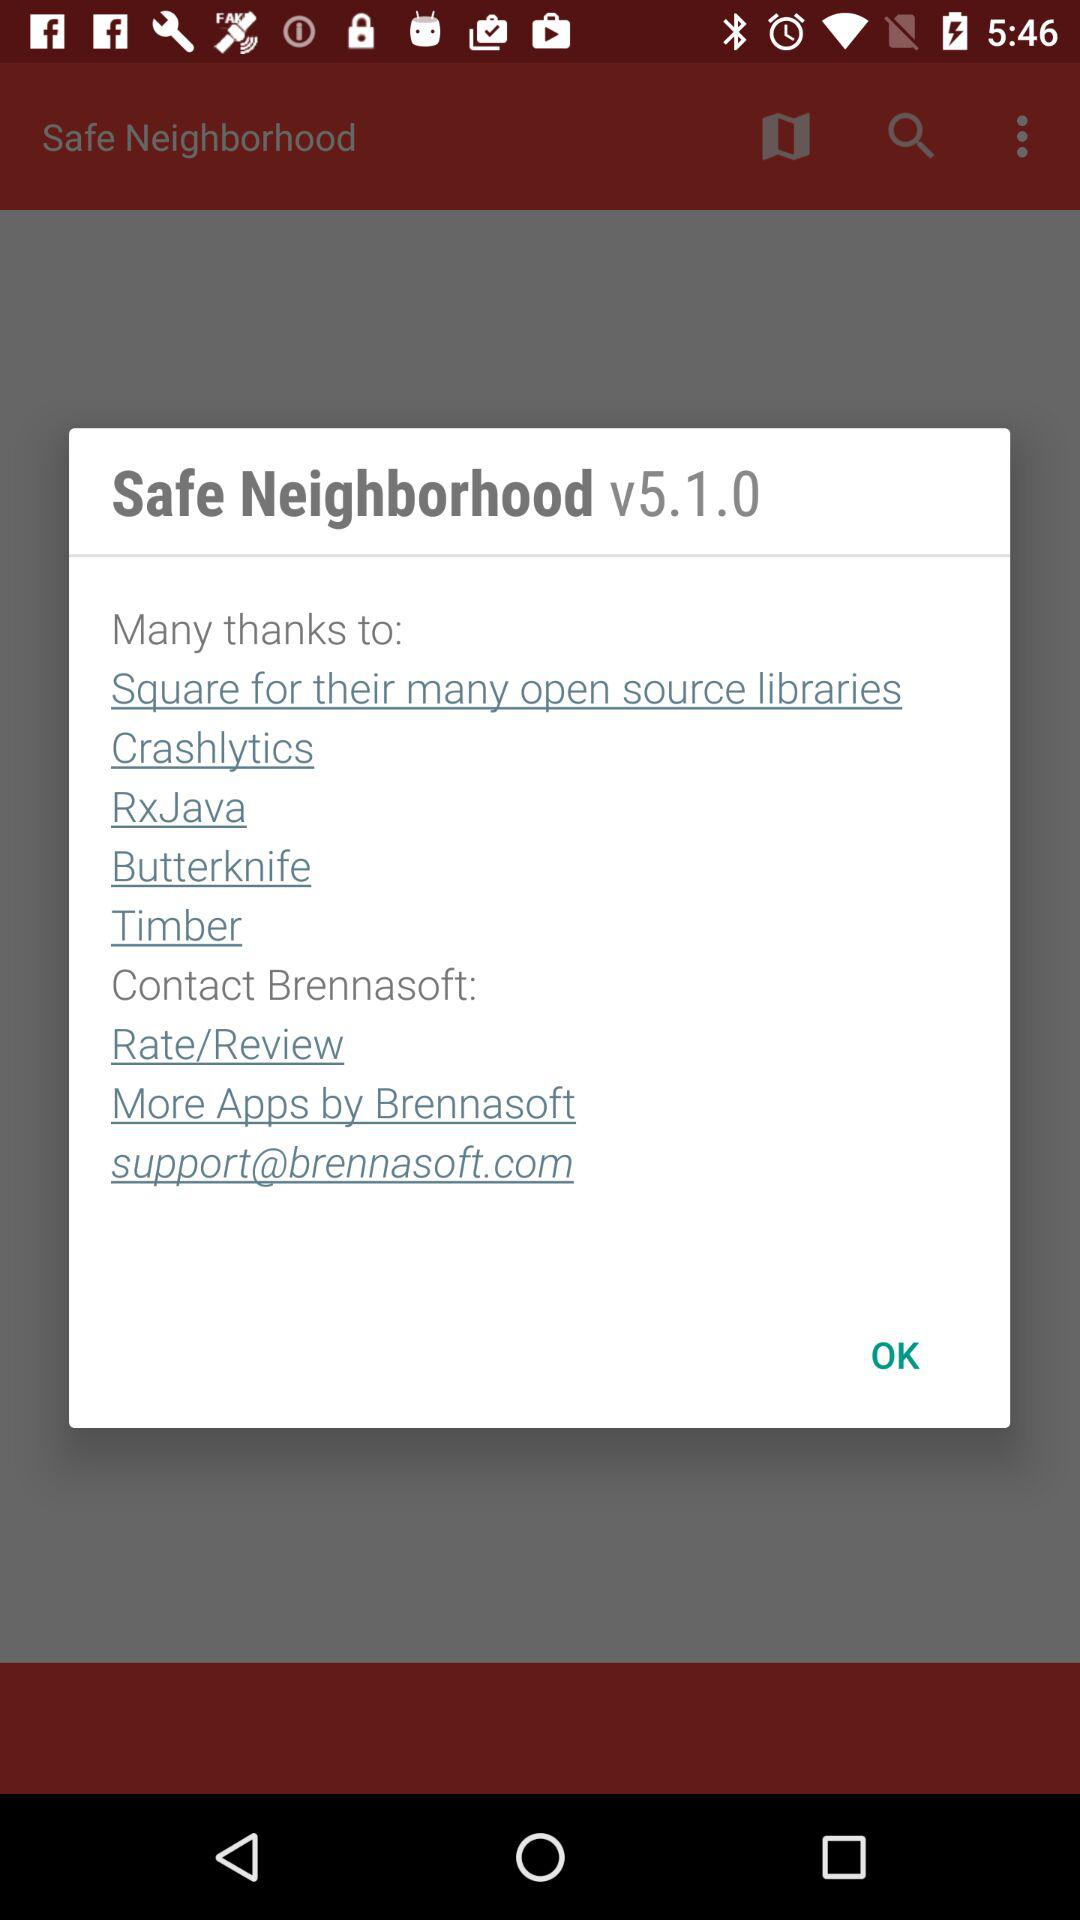What is the version number? The version number is v5.1.0. 